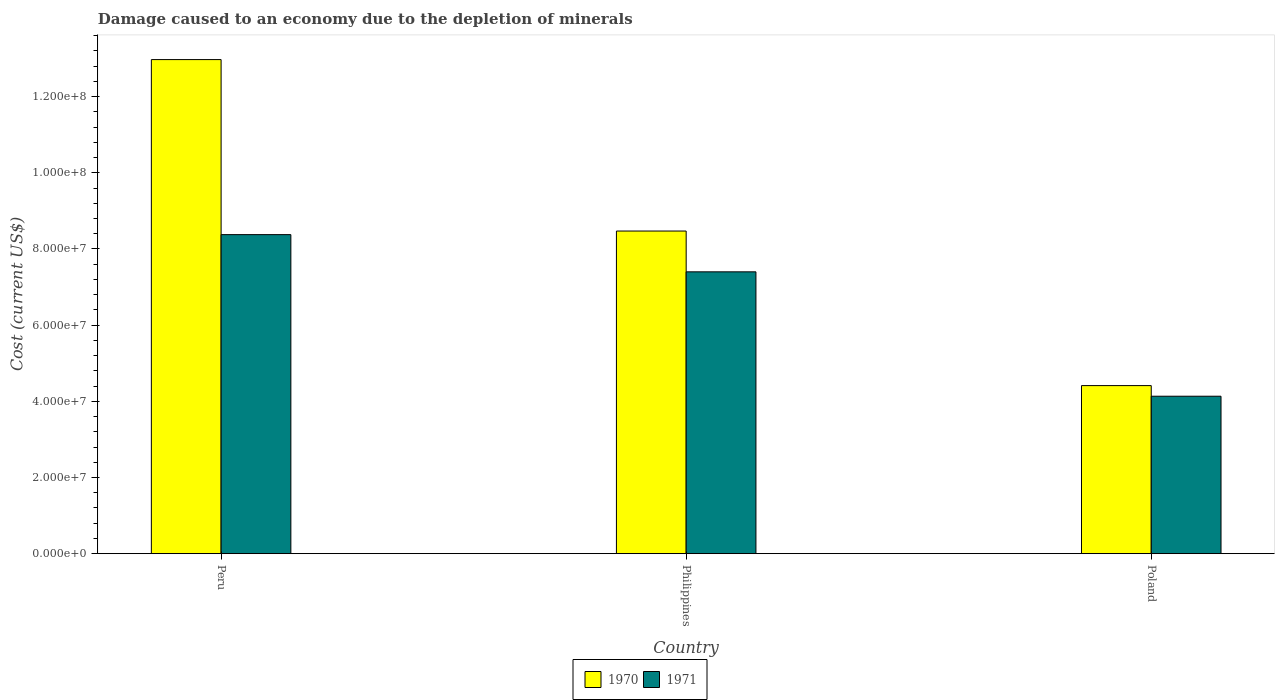How many different coloured bars are there?
Your answer should be compact. 2. How many groups of bars are there?
Give a very brief answer. 3. Are the number of bars per tick equal to the number of legend labels?
Provide a succinct answer. Yes. How many bars are there on the 3rd tick from the right?
Ensure brevity in your answer.  2. What is the cost of damage caused due to the depletion of minerals in 1970 in Philippines?
Offer a terse response. 8.47e+07. Across all countries, what is the maximum cost of damage caused due to the depletion of minerals in 1971?
Provide a short and direct response. 8.38e+07. Across all countries, what is the minimum cost of damage caused due to the depletion of minerals in 1970?
Your answer should be very brief. 4.41e+07. What is the total cost of damage caused due to the depletion of minerals in 1971 in the graph?
Provide a succinct answer. 1.99e+08. What is the difference between the cost of damage caused due to the depletion of minerals in 1970 in Philippines and that in Poland?
Make the answer very short. 4.06e+07. What is the difference between the cost of damage caused due to the depletion of minerals in 1970 in Philippines and the cost of damage caused due to the depletion of minerals in 1971 in Peru?
Make the answer very short. 9.43e+05. What is the average cost of damage caused due to the depletion of minerals in 1971 per country?
Provide a succinct answer. 6.64e+07. What is the difference between the cost of damage caused due to the depletion of minerals of/in 1970 and cost of damage caused due to the depletion of minerals of/in 1971 in Poland?
Offer a very short reply. 2.79e+06. What is the ratio of the cost of damage caused due to the depletion of minerals in 1971 in Peru to that in Philippines?
Give a very brief answer. 1.13. Is the cost of damage caused due to the depletion of minerals in 1970 in Peru less than that in Philippines?
Your response must be concise. No. What is the difference between the highest and the second highest cost of damage caused due to the depletion of minerals in 1970?
Your answer should be compact. -4.50e+07. What is the difference between the highest and the lowest cost of damage caused due to the depletion of minerals in 1970?
Your answer should be very brief. 8.56e+07. Is the sum of the cost of damage caused due to the depletion of minerals in 1970 in Peru and Poland greater than the maximum cost of damage caused due to the depletion of minerals in 1971 across all countries?
Keep it short and to the point. Yes. What does the 2nd bar from the left in Peru represents?
Keep it short and to the point. 1971. Are all the bars in the graph horizontal?
Ensure brevity in your answer.  No. What is the difference between two consecutive major ticks on the Y-axis?
Offer a terse response. 2.00e+07. Does the graph contain grids?
Your answer should be very brief. No. Where does the legend appear in the graph?
Offer a terse response. Bottom center. How are the legend labels stacked?
Your response must be concise. Horizontal. What is the title of the graph?
Make the answer very short. Damage caused to an economy due to the depletion of minerals. What is the label or title of the Y-axis?
Provide a succinct answer. Cost (current US$). What is the Cost (current US$) of 1970 in Peru?
Make the answer very short. 1.30e+08. What is the Cost (current US$) of 1971 in Peru?
Provide a succinct answer. 8.38e+07. What is the Cost (current US$) of 1970 in Philippines?
Your answer should be compact. 8.47e+07. What is the Cost (current US$) of 1971 in Philippines?
Your response must be concise. 7.40e+07. What is the Cost (current US$) in 1970 in Poland?
Offer a terse response. 4.41e+07. What is the Cost (current US$) of 1971 in Poland?
Offer a very short reply. 4.13e+07. Across all countries, what is the maximum Cost (current US$) of 1970?
Give a very brief answer. 1.30e+08. Across all countries, what is the maximum Cost (current US$) of 1971?
Give a very brief answer. 8.38e+07. Across all countries, what is the minimum Cost (current US$) of 1970?
Your response must be concise. 4.41e+07. Across all countries, what is the minimum Cost (current US$) in 1971?
Give a very brief answer. 4.13e+07. What is the total Cost (current US$) in 1970 in the graph?
Offer a very short reply. 2.59e+08. What is the total Cost (current US$) of 1971 in the graph?
Keep it short and to the point. 1.99e+08. What is the difference between the Cost (current US$) in 1970 in Peru and that in Philippines?
Provide a short and direct response. 4.50e+07. What is the difference between the Cost (current US$) in 1971 in Peru and that in Philippines?
Your answer should be very brief. 9.77e+06. What is the difference between the Cost (current US$) in 1970 in Peru and that in Poland?
Your answer should be compact. 8.56e+07. What is the difference between the Cost (current US$) of 1971 in Peru and that in Poland?
Make the answer very short. 4.24e+07. What is the difference between the Cost (current US$) of 1970 in Philippines and that in Poland?
Ensure brevity in your answer.  4.06e+07. What is the difference between the Cost (current US$) in 1971 in Philippines and that in Poland?
Provide a short and direct response. 3.27e+07. What is the difference between the Cost (current US$) in 1970 in Peru and the Cost (current US$) in 1971 in Philippines?
Your response must be concise. 5.57e+07. What is the difference between the Cost (current US$) of 1970 in Peru and the Cost (current US$) of 1971 in Poland?
Provide a short and direct response. 8.84e+07. What is the difference between the Cost (current US$) of 1970 in Philippines and the Cost (current US$) of 1971 in Poland?
Your response must be concise. 4.34e+07. What is the average Cost (current US$) in 1970 per country?
Keep it short and to the point. 8.62e+07. What is the average Cost (current US$) in 1971 per country?
Give a very brief answer. 6.64e+07. What is the difference between the Cost (current US$) in 1970 and Cost (current US$) in 1971 in Peru?
Your answer should be very brief. 4.60e+07. What is the difference between the Cost (current US$) of 1970 and Cost (current US$) of 1971 in Philippines?
Offer a very short reply. 1.07e+07. What is the difference between the Cost (current US$) of 1970 and Cost (current US$) of 1971 in Poland?
Offer a terse response. 2.79e+06. What is the ratio of the Cost (current US$) in 1970 in Peru to that in Philippines?
Your answer should be compact. 1.53. What is the ratio of the Cost (current US$) in 1971 in Peru to that in Philippines?
Provide a short and direct response. 1.13. What is the ratio of the Cost (current US$) of 1970 in Peru to that in Poland?
Give a very brief answer. 2.94. What is the ratio of the Cost (current US$) in 1971 in Peru to that in Poland?
Provide a short and direct response. 2.03. What is the ratio of the Cost (current US$) of 1970 in Philippines to that in Poland?
Your response must be concise. 1.92. What is the ratio of the Cost (current US$) of 1971 in Philippines to that in Poland?
Offer a very short reply. 1.79. What is the difference between the highest and the second highest Cost (current US$) in 1970?
Your answer should be compact. 4.50e+07. What is the difference between the highest and the second highest Cost (current US$) in 1971?
Your answer should be very brief. 9.77e+06. What is the difference between the highest and the lowest Cost (current US$) in 1970?
Provide a succinct answer. 8.56e+07. What is the difference between the highest and the lowest Cost (current US$) in 1971?
Your answer should be very brief. 4.24e+07. 